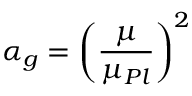Convert formula to latex. <formula><loc_0><loc_0><loc_500><loc_500>\alpha _ { g } = \left ( \frac { \mu } { \mu _ { P l } } \right ) ^ { 2 }</formula> 